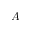<formula> <loc_0><loc_0><loc_500><loc_500>A</formula> 